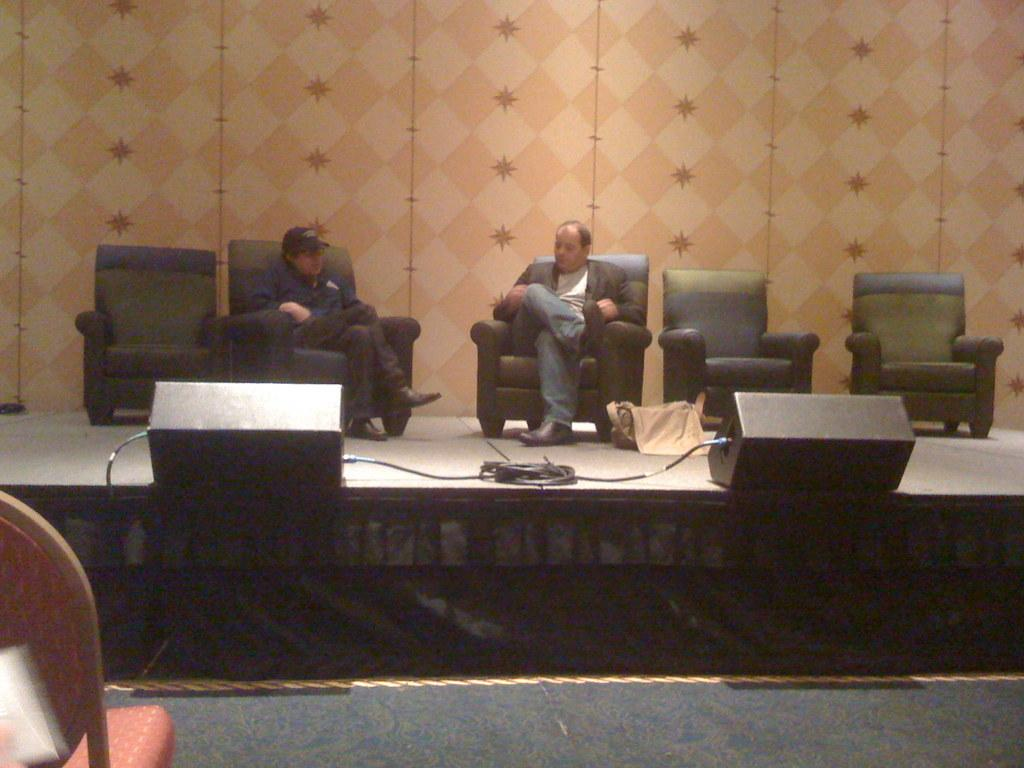How many people are in the image? There are two people in the image. What are the two people doing in the image? The two people are sitting on a sofa. Where is the sofa located in the image? The sofa is on a stage. What type of guide is present on the stage in the image? There is no guide present in the image; it only features two people sitting on a sofa on a stage. 